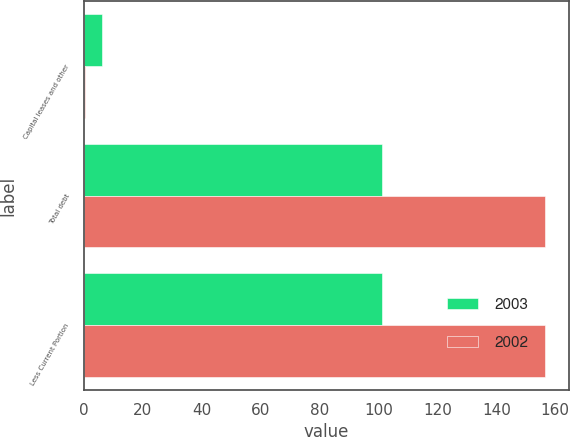<chart> <loc_0><loc_0><loc_500><loc_500><stacked_bar_chart><ecel><fcel>Capital leases and other<fcel>Total debt<fcel>Less Current Portion<nl><fcel>2003<fcel>6.1<fcel>101.3<fcel>101.3<nl><fcel>2002<fcel>0.5<fcel>156.7<fcel>156.7<nl></chart> 